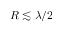Convert formula to latex. <formula><loc_0><loc_0><loc_500><loc_500>R \lesssim \lambda / 2</formula> 